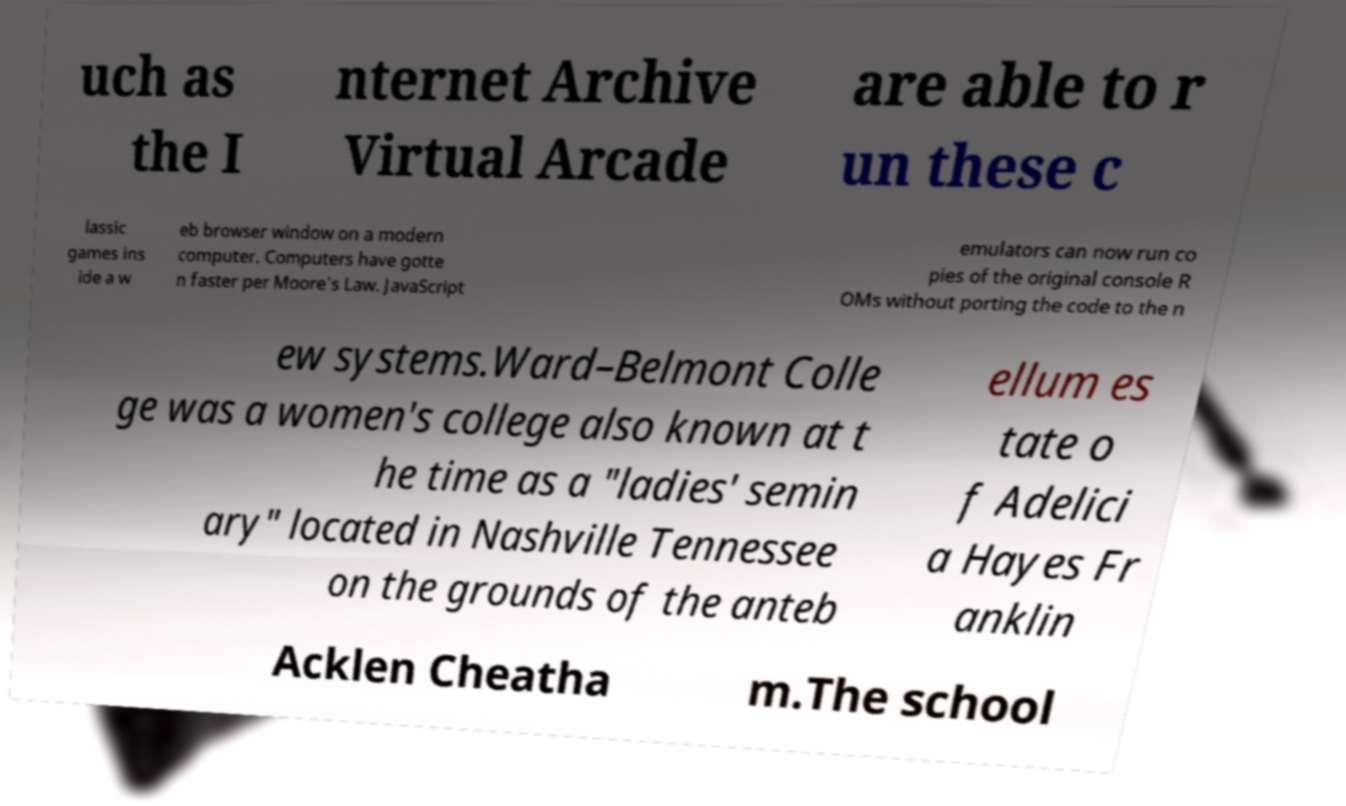I need the written content from this picture converted into text. Can you do that? uch as the I nternet Archive Virtual Arcade are able to r un these c lassic games ins ide a w eb browser window on a modern computer. Computers have gotte n faster per Moore's Law. JavaScript emulators can now run co pies of the original console R OMs without porting the code to the n ew systems.Ward–Belmont Colle ge was a women's college also known at t he time as a "ladies' semin ary" located in Nashville Tennessee on the grounds of the anteb ellum es tate o f Adelici a Hayes Fr anklin Acklen Cheatha m.The school 